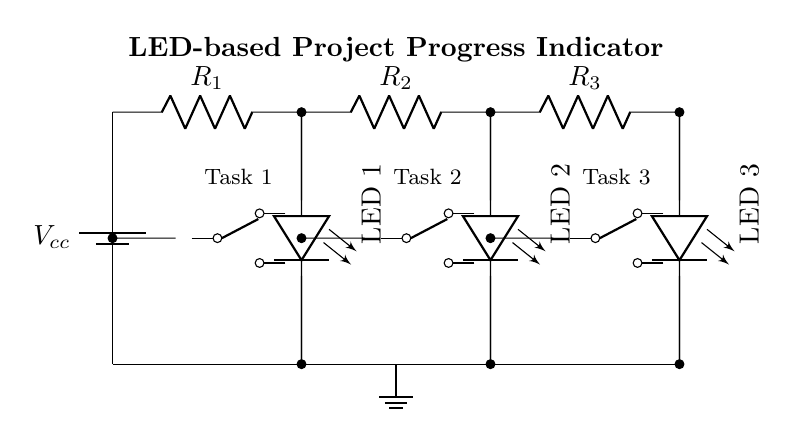What voltage is supplied by the battery? The voltage supplied by the battery is denoted as Vcc, which represents the power source for the circuit.
Answer: Vcc How many LEDs are present in the circuit? The circuit diagram shows three LED components, each connected to a switch to indicate the status of different tasks.
Answer: Three What are the names of the tasks controlled by the switches? The circuit indicates three tasks, labeled as Task 1, Task 2, and Task 3, which correspond to the three SPDT switches.
Answer: Task 1, Task 2, Task 3 What is the purpose of the resistors in this circuit? The resistors R1, R2, and R3 serve to limit the current flowing through the LEDs, preventing damage and ensuring safe operation.
Answer: Current limiting If all tasks are completed, how many LEDs will be turned on? If all tasks are completed, the SPDT switches for each task will be closed, allowing all three LEDs to light up simultaneously.
Answer: Three How are the tasks visually represented in the circuit? The tasks are represented by three SPDT switches, each connected to an LED that indicates the completion status of its respective task.
Answer: SPDT switches 